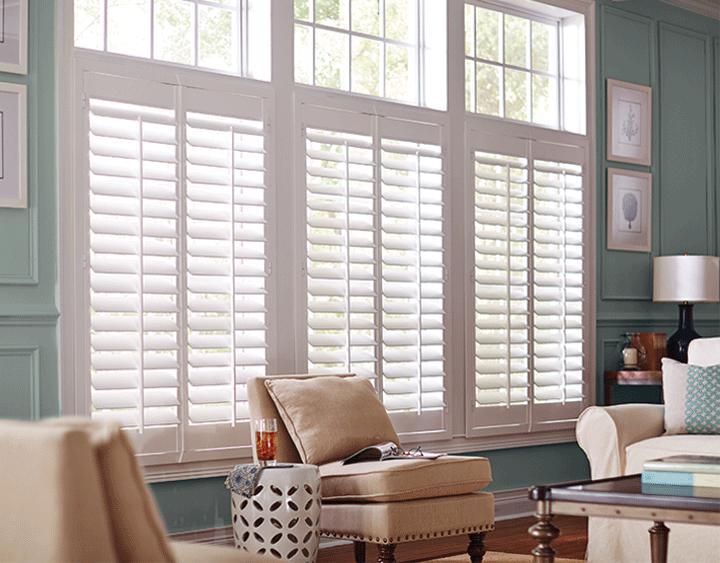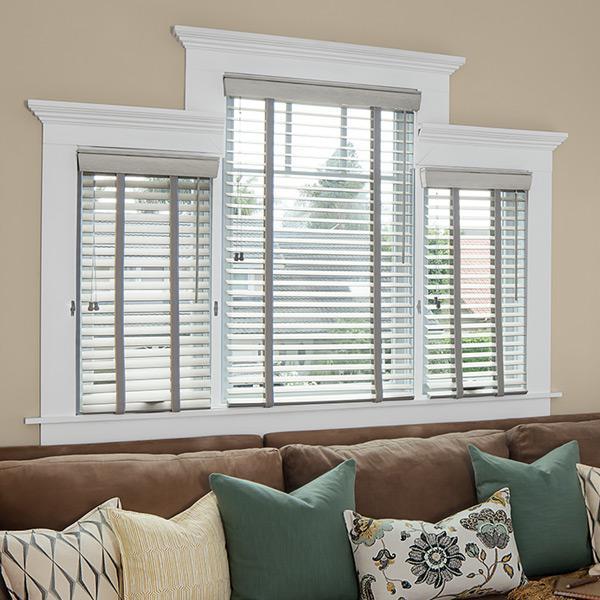The first image is the image on the left, the second image is the image on the right. Considering the images on both sides, is "The left and right image contains a total of six blinds." valid? Answer yes or no. Yes. The first image is the image on the left, the second image is the image on the right. Assess this claim about the two images: "there are three windows with white trim and a sofa with pillows in front of it". Correct or not? Answer yes or no. Yes. 